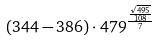Convert formula to latex. <formula><loc_0><loc_0><loc_500><loc_500>( 3 4 4 - 3 8 6 ) \cdot 4 7 9 ^ { \frac { \frac { \sqrt { 4 9 5 } } { 1 0 8 } } { 7 } }</formula> 